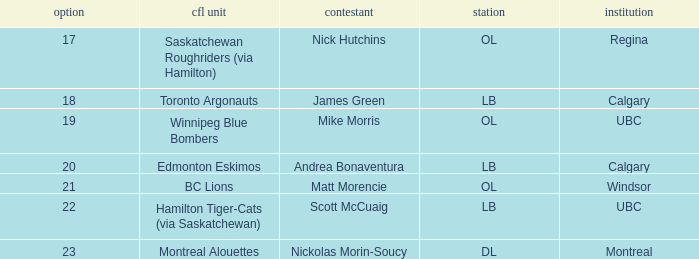Who is a player in the bc lions team? Matt Morencie. Could you help me parse every detail presented in this table? {'header': ['option', 'cfl unit', 'contestant', 'station', 'institution'], 'rows': [['17', 'Saskatchewan Roughriders (via Hamilton)', 'Nick Hutchins', 'OL', 'Regina'], ['18', 'Toronto Argonauts', 'James Green', 'LB', 'Calgary'], ['19', 'Winnipeg Blue Bombers', 'Mike Morris', 'OL', 'UBC'], ['20', 'Edmonton Eskimos', 'Andrea Bonaventura', 'LB', 'Calgary'], ['21', 'BC Lions', 'Matt Morencie', 'OL', 'Windsor'], ['22', 'Hamilton Tiger-Cats (via Saskatchewan)', 'Scott McCuaig', 'LB', 'UBC'], ['23', 'Montreal Alouettes', 'Nickolas Morin-Soucy', 'DL', 'Montreal']]} 